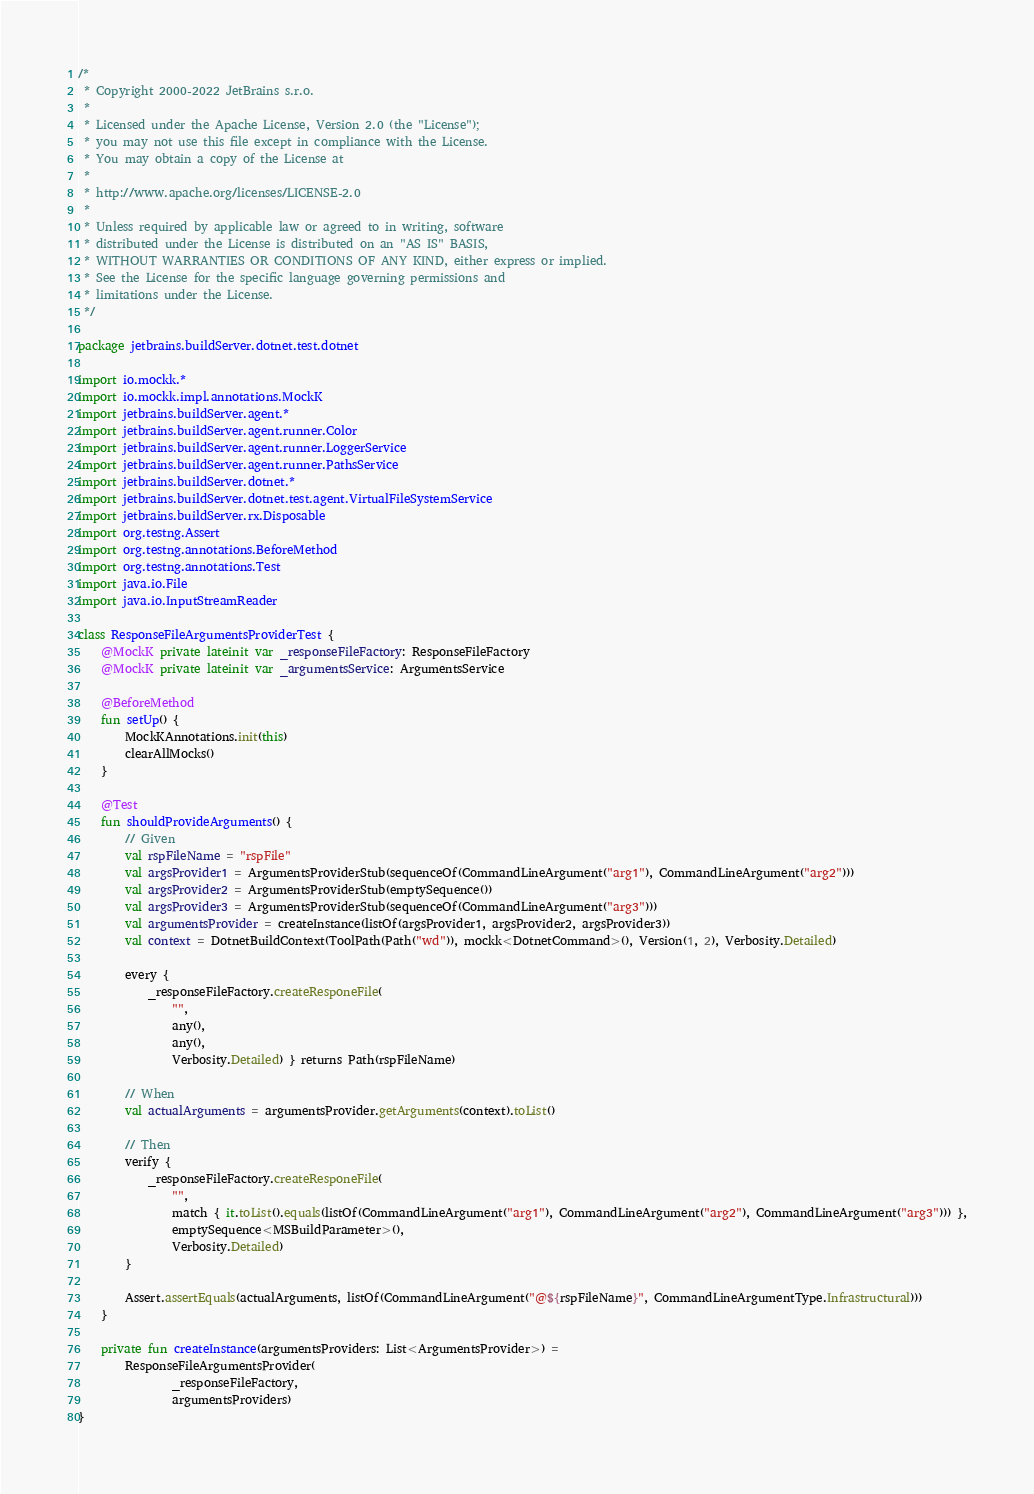<code> <loc_0><loc_0><loc_500><loc_500><_Kotlin_>/*
 * Copyright 2000-2022 JetBrains s.r.o.
 *
 * Licensed under the Apache License, Version 2.0 (the "License");
 * you may not use this file except in compliance with the License.
 * You may obtain a copy of the License at
 *
 * http://www.apache.org/licenses/LICENSE-2.0
 *
 * Unless required by applicable law or agreed to in writing, software
 * distributed under the License is distributed on an "AS IS" BASIS,
 * WITHOUT WARRANTIES OR CONDITIONS OF ANY KIND, either express or implied.
 * See the License for the specific language governing permissions and
 * limitations under the License.
 */

package jetbrains.buildServer.dotnet.test.dotnet

import io.mockk.*
import io.mockk.impl.annotations.MockK
import jetbrains.buildServer.agent.*
import jetbrains.buildServer.agent.runner.Color
import jetbrains.buildServer.agent.runner.LoggerService
import jetbrains.buildServer.agent.runner.PathsService
import jetbrains.buildServer.dotnet.*
import jetbrains.buildServer.dotnet.test.agent.VirtualFileSystemService
import jetbrains.buildServer.rx.Disposable
import org.testng.Assert
import org.testng.annotations.BeforeMethod
import org.testng.annotations.Test
import java.io.File
import java.io.InputStreamReader

class ResponseFileArgumentsProviderTest {
    @MockK private lateinit var _responseFileFactory: ResponseFileFactory
    @MockK private lateinit var _argumentsService: ArgumentsService

    @BeforeMethod
    fun setUp() {
        MockKAnnotations.init(this)
        clearAllMocks()
    }

    @Test
    fun shouldProvideArguments() {
        // Given
        val rspFileName = "rspFile"
        val argsProvider1 = ArgumentsProviderStub(sequenceOf(CommandLineArgument("arg1"), CommandLineArgument("arg2")))
        val argsProvider2 = ArgumentsProviderStub(emptySequence())
        val argsProvider3 = ArgumentsProviderStub(sequenceOf(CommandLineArgument("arg3")))
        val argumentsProvider = createInstance(listOf(argsProvider1, argsProvider2, argsProvider3))
        val context = DotnetBuildContext(ToolPath(Path("wd")), mockk<DotnetCommand>(), Version(1, 2), Verbosity.Detailed)

        every {
            _responseFileFactory.createResponeFile(
                "",
                any(),
                any(),
                Verbosity.Detailed) } returns Path(rspFileName)

        // When
        val actualArguments = argumentsProvider.getArguments(context).toList()

        // Then
        verify {
            _responseFileFactory.createResponeFile(
                "",
                match { it.toList().equals(listOf(CommandLineArgument("arg1"), CommandLineArgument("arg2"), CommandLineArgument("arg3"))) },
                emptySequence<MSBuildParameter>(),
                Verbosity.Detailed)
        }

        Assert.assertEquals(actualArguments, listOf(CommandLineArgument("@${rspFileName}", CommandLineArgumentType.Infrastructural)))
    }

    private fun createInstance(argumentsProviders: List<ArgumentsProvider>) =
        ResponseFileArgumentsProvider(
                _responseFileFactory,
                argumentsProviders)
}</code> 